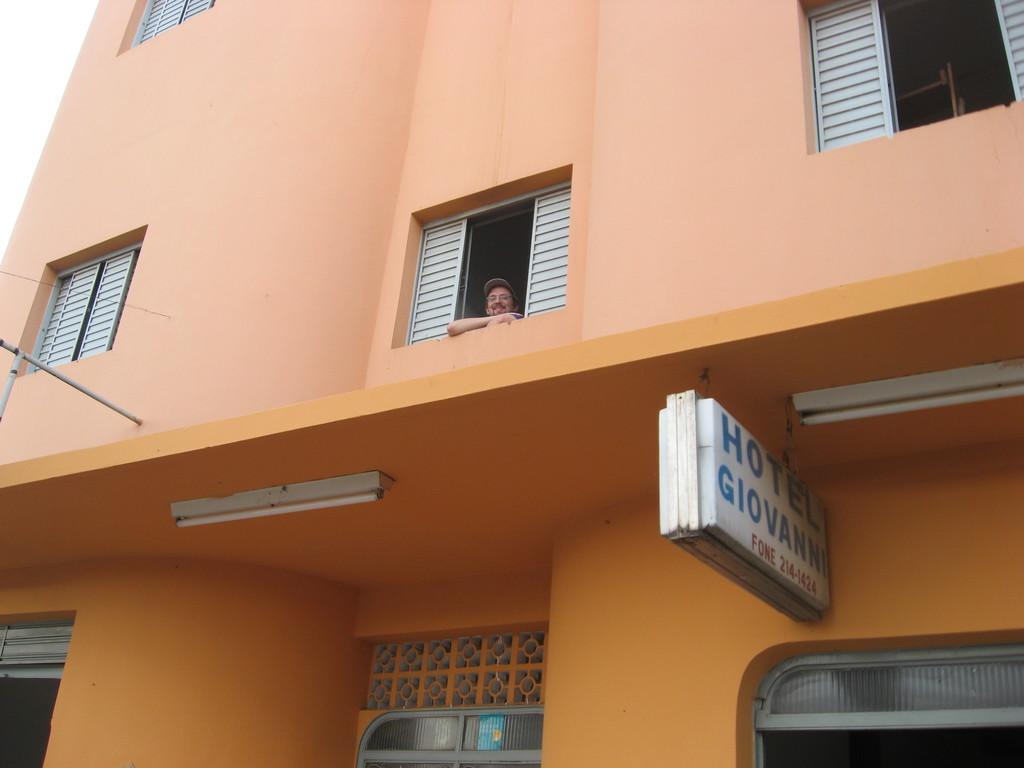What type of building is shown in the image? The image depicts a hotel. How many windows can be seen on the hotel? The hotel has many windows. Is there any activity visible through the windows? Yes, a person is visible from one of the windows. What is the person doing in the image? The person is peeing outside. What is the color of the hotel building? The building is in peach color. What type of cork can be seen in the image? There is no cork present in the image. Can you tell me the account number of the person visible in the image? There is no account number mentioned or visible in the image. 